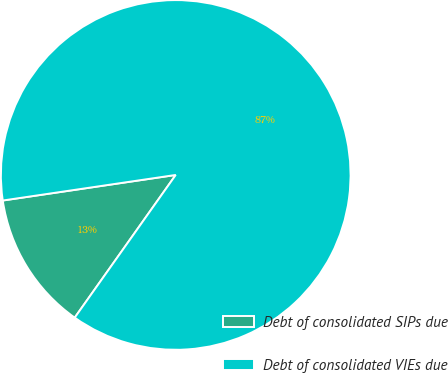Convert chart to OTSL. <chart><loc_0><loc_0><loc_500><loc_500><pie_chart><fcel>Debt of consolidated SIPs due<fcel>Debt of consolidated VIEs due<nl><fcel>12.86%<fcel>87.14%<nl></chart> 